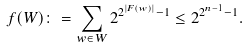Convert formula to latex. <formula><loc_0><loc_0><loc_500><loc_500>f ( W ) \colon = \sum _ { w \in W } 2 ^ { 2 ^ { | F ( w ) | } - 1 } \leq 2 ^ { 2 ^ { n - 1 } - 1 } .</formula> 